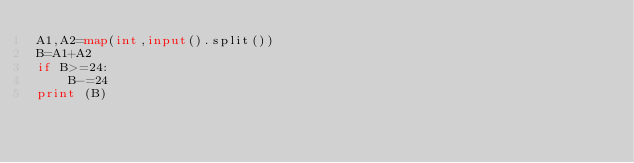<code> <loc_0><loc_0><loc_500><loc_500><_Python_>A1,A2=map(int,input().split())
B=A1+A2
if B>=24:
    B-=24
print (B)
</code> 